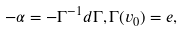<formula> <loc_0><loc_0><loc_500><loc_500>- \alpha = - \Gamma ^ { - 1 } d \Gamma , \Gamma ( v _ { 0 } ) = e ,</formula> 